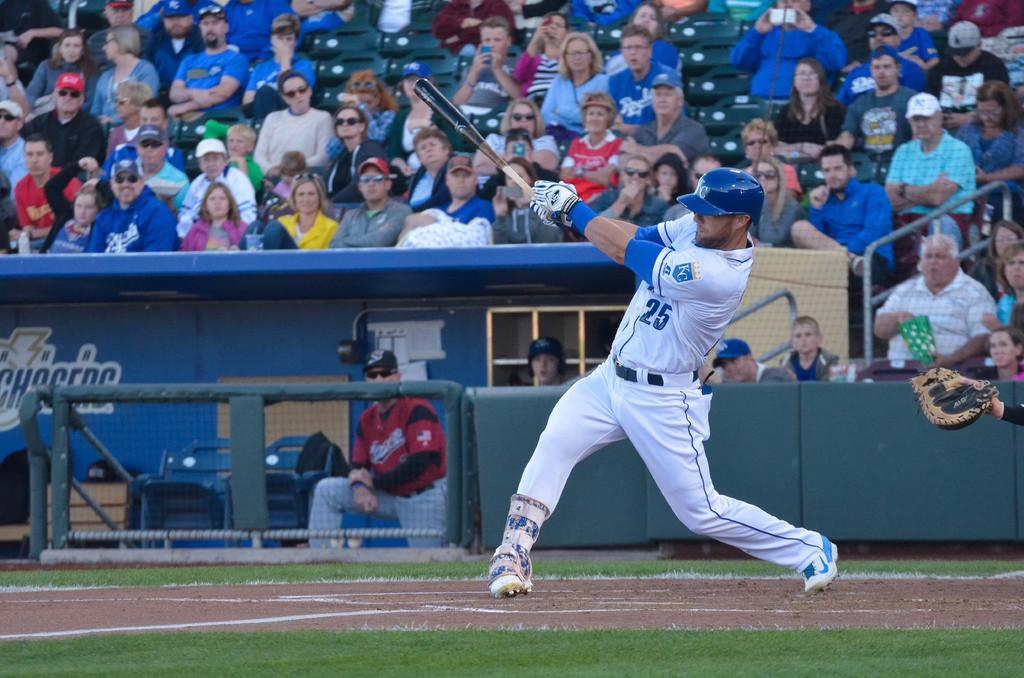<image>
Share a concise interpretation of the image provided. A baseball player that is wearing the number 25 on his jersey swings a bat. 